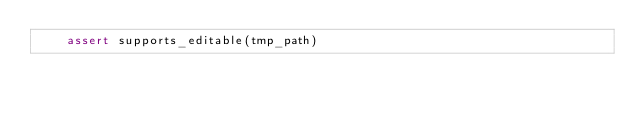<code> <loc_0><loc_0><loc_500><loc_500><_Python_>    assert supports_editable(tmp_path)
</code> 